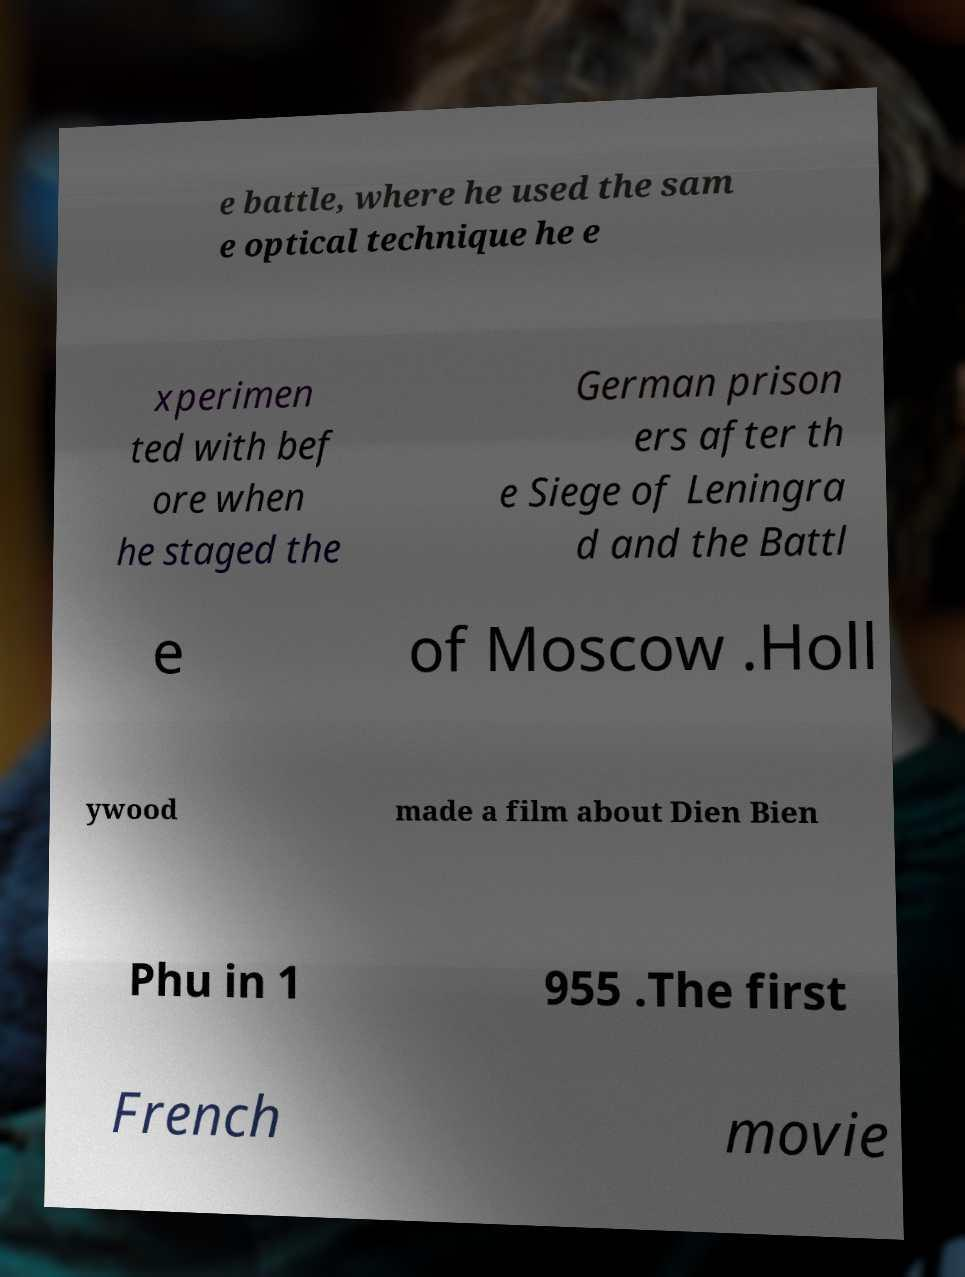Could you extract and type out the text from this image? e battle, where he used the sam e optical technique he e xperimen ted with bef ore when he staged the German prison ers after th e Siege of Leningra d and the Battl e of Moscow .Holl ywood made a film about Dien Bien Phu in 1 955 .The first French movie 